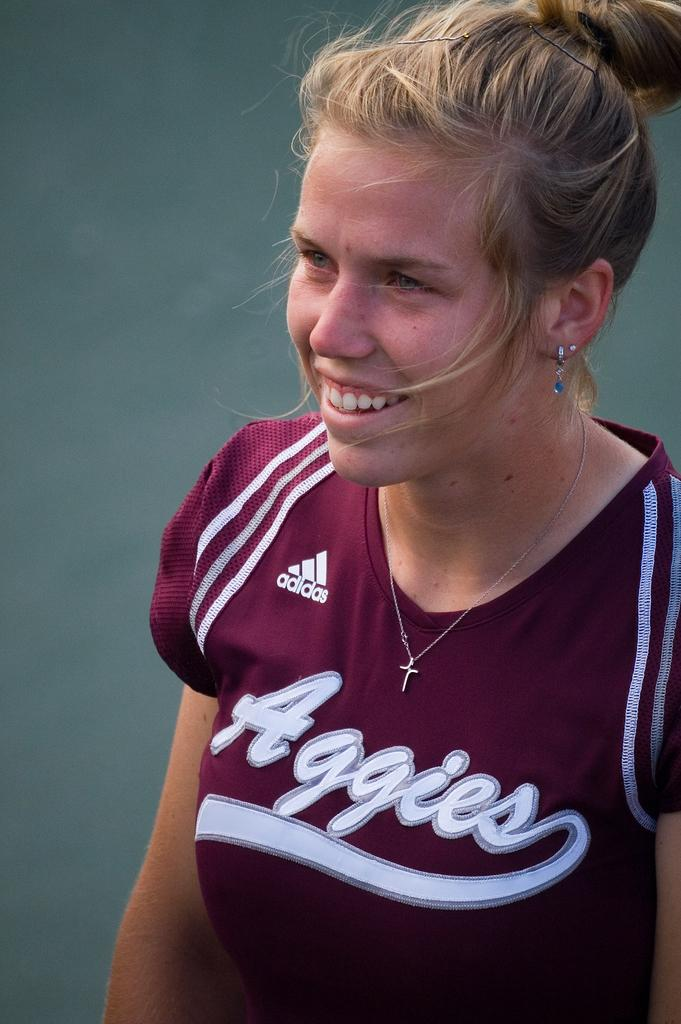<image>
Describe the image concisely. Girl wearing a purple shirt which is sponsored by Adidas. 